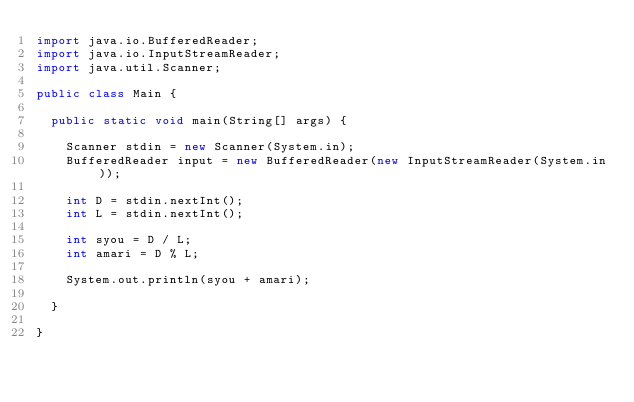Convert code to text. <code><loc_0><loc_0><loc_500><loc_500><_Java_>import java.io.BufferedReader;
import java.io.InputStreamReader;
import java.util.Scanner;

public class Main {

	public static void main(String[] args) {

		Scanner stdin = new Scanner(System.in);
		BufferedReader input = new BufferedReader(new InputStreamReader(System.in));

		int D = stdin.nextInt();
		int L = stdin.nextInt();
		
		int syou = D / L;
		int amari = D % L;
		
		System.out.println(syou + amari);
		
	}

}</code> 